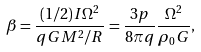Convert formula to latex. <formula><loc_0><loc_0><loc_500><loc_500>\beta = \frac { ( 1 / 2 ) I \Omega ^ { 2 } } { q G M ^ { 2 } / R } = \frac { 3 p } { 8 \pi q } \frac { { \Omega } ^ { 2 } } { { \rho } _ { 0 } G } ,</formula> 